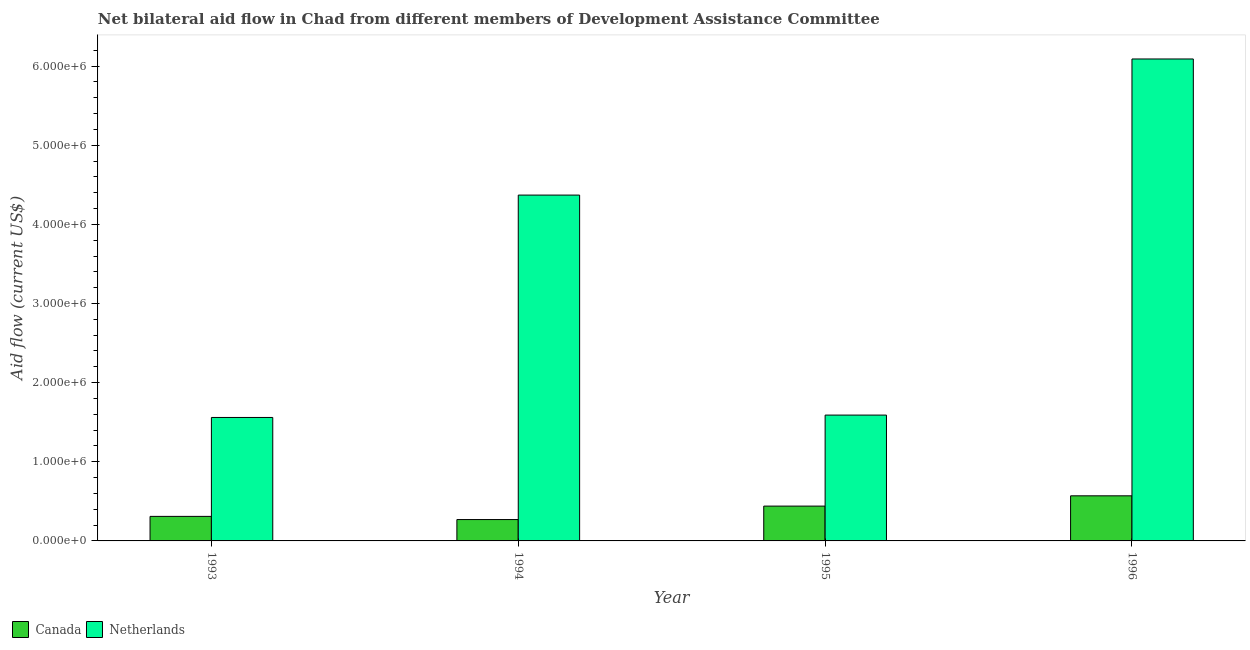How many different coloured bars are there?
Make the answer very short. 2. How many groups of bars are there?
Provide a succinct answer. 4. Are the number of bars on each tick of the X-axis equal?
Keep it short and to the point. Yes. In how many cases, is the number of bars for a given year not equal to the number of legend labels?
Offer a very short reply. 0. What is the amount of aid given by canada in 1993?
Keep it short and to the point. 3.10e+05. Across all years, what is the maximum amount of aid given by canada?
Keep it short and to the point. 5.70e+05. Across all years, what is the minimum amount of aid given by netherlands?
Provide a succinct answer. 1.56e+06. In which year was the amount of aid given by canada maximum?
Keep it short and to the point. 1996. In which year was the amount of aid given by netherlands minimum?
Keep it short and to the point. 1993. What is the total amount of aid given by canada in the graph?
Provide a short and direct response. 1.59e+06. What is the difference between the amount of aid given by canada in 1995 and that in 1996?
Provide a short and direct response. -1.30e+05. What is the difference between the amount of aid given by netherlands in 1995 and the amount of aid given by canada in 1993?
Give a very brief answer. 3.00e+04. What is the average amount of aid given by netherlands per year?
Provide a short and direct response. 3.40e+06. In how many years, is the amount of aid given by canada greater than 3200000 US$?
Ensure brevity in your answer.  0. What is the ratio of the amount of aid given by canada in 1994 to that in 1996?
Ensure brevity in your answer.  0.47. Is the amount of aid given by netherlands in 1993 less than that in 1996?
Offer a terse response. Yes. What is the difference between the highest and the second highest amount of aid given by netherlands?
Offer a very short reply. 1.72e+06. What is the difference between the highest and the lowest amount of aid given by canada?
Your answer should be very brief. 3.00e+05. In how many years, is the amount of aid given by netherlands greater than the average amount of aid given by netherlands taken over all years?
Give a very brief answer. 2. Is the sum of the amount of aid given by netherlands in 1994 and 1996 greater than the maximum amount of aid given by canada across all years?
Provide a succinct answer. Yes. What does the 2nd bar from the left in 1993 represents?
Your answer should be very brief. Netherlands. What does the 1st bar from the right in 1993 represents?
Offer a very short reply. Netherlands. Are all the bars in the graph horizontal?
Offer a terse response. No. How many years are there in the graph?
Your response must be concise. 4. Does the graph contain grids?
Your response must be concise. No. How are the legend labels stacked?
Give a very brief answer. Horizontal. What is the title of the graph?
Provide a short and direct response. Net bilateral aid flow in Chad from different members of Development Assistance Committee. What is the label or title of the Y-axis?
Give a very brief answer. Aid flow (current US$). What is the Aid flow (current US$) in Canada in 1993?
Offer a very short reply. 3.10e+05. What is the Aid flow (current US$) of Netherlands in 1993?
Offer a very short reply. 1.56e+06. What is the Aid flow (current US$) of Netherlands in 1994?
Offer a very short reply. 4.37e+06. What is the Aid flow (current US$) in Canada in 1995?
Your response must be concise. 4.40e+05. What is the Aid flow (current US$) in Netherlands in 1995?
Your answer should be very brief. 1.59e+06. What is the Aid flow (current US$) in Canada in 1996?
Your response must be concise. 5.70e+05. What is the Aid flow (current US$) in Netherlands in 1996?
Provide a succinct answer. 6.09e+06. Across all years, what is the maximum Aid flow (current US$) of Canada?
Your answer should be compact. 5.70e+05. Across all years, what is the maximum Aid flow (current US$) of Netherlands?
Provide a short and direct response. 6.09e+06. Across all years, what is the minimum Aid flow (current US$) in Canada?
Your answer should be compact. 2.70e+05. Across all years, what is the minimum Aid flow (current US$) of Netherlands?
Provide a succinct answer. 1.56e+06. What is the total Aid flow (current US$) of Canada in the graph?
Your answer should be very brief. 1.59e+06. What is the total Aid flow (current US$) of Netherlands in the graph?
Offer a terse response. 1.36e+07. What is the difference between the Aid flow (current US$) in Netherlands in 1993 and that in 1994?
Ensure brevity in your answer.  -2.81e+06. What is the difference between the Aid flow (current US$) in Netherlands in 1993 and that in 1995?
Your answer should be compact. -3.00e+04. What is the difference between the Aid flow (current US$) of Canada in 1993 and that in 1996?
Your answer should be very brief. -2.60e+05. What is the difference between the Aid flow (current US$) of Netherlands in 1993 and that in 1996?
Provide a succinct answer. -4.53e+06. What is the difference between the Aid flow (current US$) in Netherlands in 1994 and that in 1995?
Offer a terse response. 2.78e+06. What is the difference between the Aid flow (current US$) in Canada in 1994 and that in 1996?
Keep it short and to the point. -3.00e+05. What is the difference between the Aid flow (current US$) in Netherlands in 1994 and that in 1996?
Make the answer very short. -1.72e+06. What is the difference between the Aid flow (current US$) of Canada in 1995 and that in 1996?
Make the answer very short. -1.30e+05. What is the difference between the Aid flow (current US$) in Netherlands in 1995 and that in 1996?
Ensure brevity in your answer.  -4.50e+06. What is the difference between the Aid flow (current US$) in Canada in 1993 and the Aid flow (current US$) in Netherlands in 1994?
Offer a very short reply. -4.06e+06. What is the difference between the Aid flow (current US$) of Canada in 1993 and the Aid flow (current US$) of Netherlands in 1995?
Your answer should be compact. -1.28e+06. What is the difference between the Aid flow (current US$) in Canada in 1993 and the Aid flow (current US$) in Netherlands in 1996?
Your answer should be very brief. -5.78e+06. What is the difference between the Aid flow (current US$) of Canada in 1994 and the Aid flow (current US$) of Netherlands in 1995?
Offer a terse response. -1.32e+06. What is the difference between the Aid flow (current US$) in Canada in 1994 and the Aid flow (current US$) in Netherlands in 1996?
Make the answer very short. -5.82e+06. What is the difference between the Aid flow (current US$) in Canada in 1995 and the Aid flow (current US$) in Netherlands in 1996?
Give a very brief answer. -5.65e+06. What is the average Aid flow (current US$) of Canada per year?
Give a very brief answer. 3.98e+05. What is the average Aid flow (current US$) of Netherlands per year?
Keep it short and to the point. 3.40e+06. In the year 1993, what is the difference between the Aid flow (current US$) of Canada and Aid flow (current US$) of Netherlands?
Offer a very short reply. -1.25e+06. In the year 1994, what is the difference between the Aid flow (current US$) of Canada and Aid flow (current US$) of Netherlands?
Provide a succinct answer. -4.10e+06. In the year 1995, what is the difference between the Aid flow (current US$) of Canada and Aid flow (current US$) of Netherlands?
Your answer should be compact. -1.15e+06. In the year 1996, what is the difference between the Aid flow (current US$) in Canada and Aid flow (current US$) in Netherlands?
Offer a very short reply. -5.52e+06. What is the ratio of the Aid flow (current US$) of Canada in 1993 to that in 1994?
Ensure brevity in your answer.  1.15. What is the ratio of the Aid flow (current US$) in Netherlands in 1993 to that in 1994?
Provide a short and direct response. 0.36. What is the ratio of the Aid flow (current US$) in Canada in 1993 to that in 1995?
Make the answer very short. 0.7. What is the ratio of the Aid flow (current US$) of Netherlands in 1993 to that in 1995?
Offer a terse response. 0.98. What is the ratio of the Aid flow (current US$) of Canada in 1993 to that in 1996?
Ensure brevity in your answer.  0.54. What is the ratio of the Aid flow (current US$) of Netherlands in 1993 to that in 1996?
Make the answer very short. 0.26. What is the ratio of the Aid flow (current US$) of Canada in 1994 to that in 1995?
Ensure brevity in your answer.  0.61. What is the ratio of the Aid flow (current US$) in Netherlands in 1994 to that in 1995?
Ensure brevity in your answer.  2.75. What is the ratio of the Aid flow (current US$) of Canada in 1994 to that in 1996?
Provide a short and direct response. 0.47. What is the ratio of the Aid flow (current US$) of Netherlands in 1994 to that in 1996?
Offer a very short reply. 0.72. What is the ratio of the Aid flow (current US$) of Canada in 1995 to that in 1996?
Offer a very short reply. 0.77. What is the ratio of the Aid flow (current US$) of Netherlands in 1995 to that in 1996?
Provide a short and direct response. 0.26. What is the difference between the highest and the second highest Aid flow (current US$) in Canada?
Offer a terse response. 1.30e+05. What is the difference between the highest and the second highest Aid flow (current US$) of Netherlands?
Give a very brief answer. 1.72e+06. What is the difference between the highest and the lowest Aid flow (current US$) in Netherlands?
Ensure brevity in your answer.  4.53e+06. 